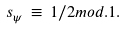<formula> <loc_0><loc_0><loc_500><loc_500>s _ { \psi } \, \equiv \, 1 / 2 m o d . 1 .</formula> 